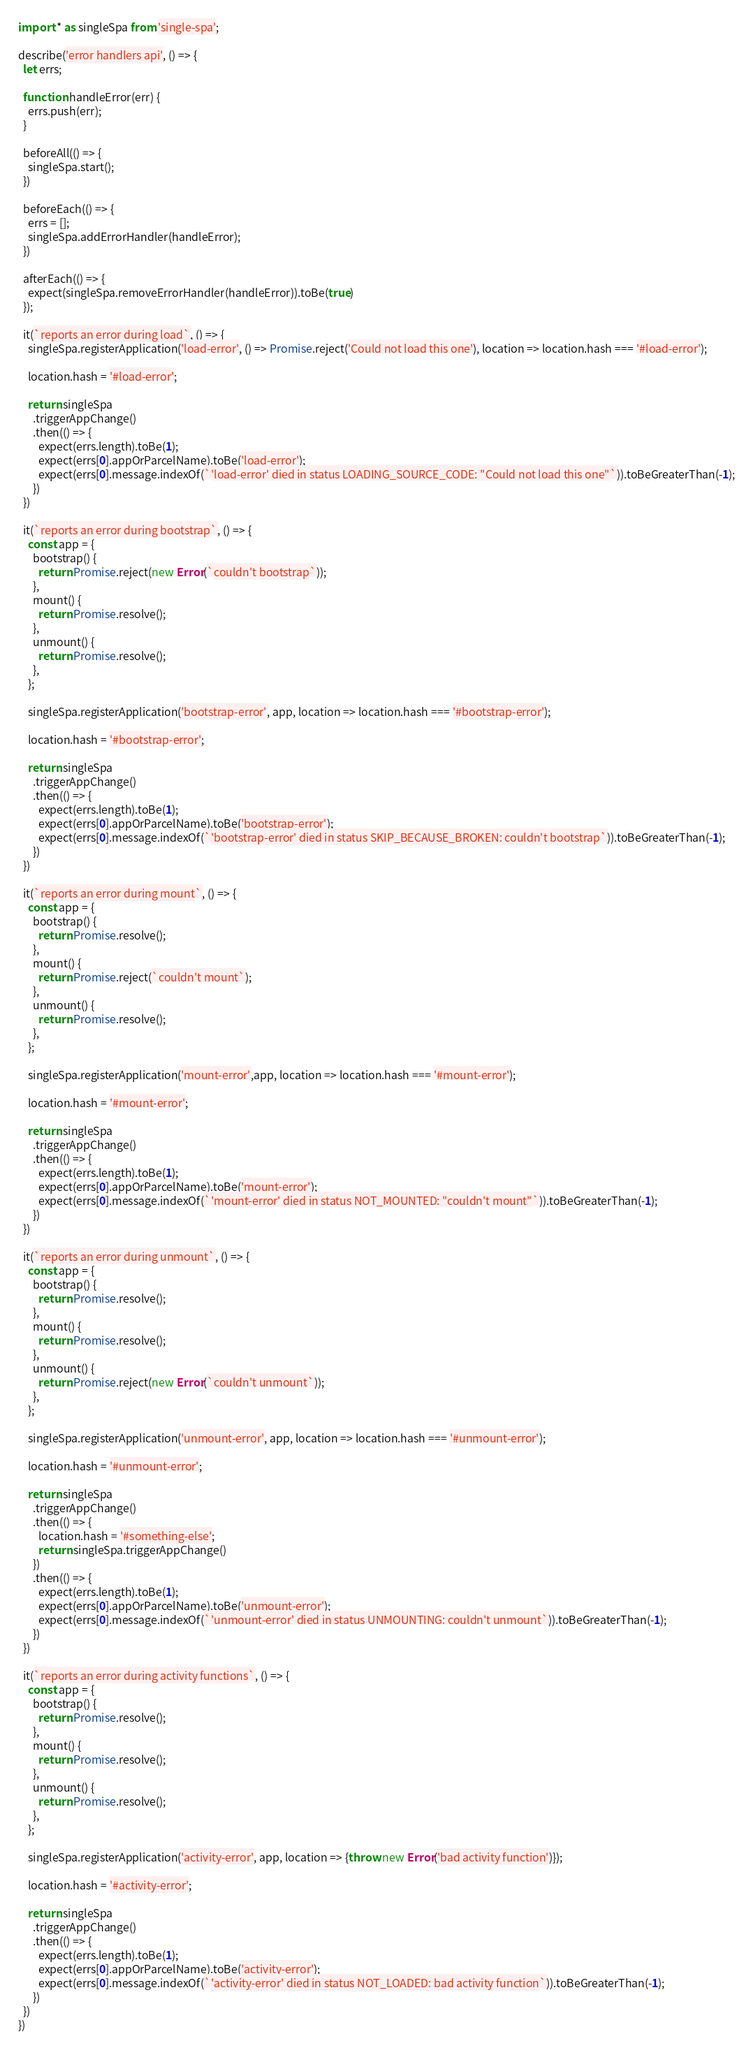Convert code to text. <code><loc_0><loc_0><loc_500><loc_500><_JavaScript_>import * as singleSpa from 'single-spa';

describe('error handlers api', () => {
  let errs;

  function handleError(err) {
    errs.push(err);
  }

  beforeAll(() => {
    singleSpa.start();
  })

  beforeEach(() => {
    errs = [];
    singleSpa.addErrorHandler(handleError);
  })

  afterEach(() => {
    expect(singleSpa.removeErrorHandler(handleError)).toBe(true)
  });

  it(`reports an error during load`, () => {
    singleSpa.registerApplication('load-error', () => Promise.reject('Could not load this one'), location => location.hash === '#load-error');

    location.hash = '#load-error';

    return singleSpa
      .triggerAppChange()
      .then(() => {
        expect(errs.length).toBe(1);
        expect(errs[0].appOrParcelName).toBe('load-error');
        expect(errs[0].message.indexOf(`'load-error' died in status LOADING_SOURCE_CODE: "Could not load this one"`)).toBeGreaterThan(-1);
      })
  })

  it(`reports an error during bootstrap`, () => {
    const app = {
      bootstrap() {
        return Promise.reject(new Error(`couldn't bootstrap`));
      },
      mount() {
        return Promise.resolve();
      },
      unmount() {
        return Promise.resolve();
      },
    };

    singleSpa.registerApplication('bootstrap-error', app, location => location.hash === '#bootstrap-error');

    location.hash = '#bootstrap-error';

    return singleSpa
      .triggerAppChange()
      .then(() => {
        expect(errs.length).toBe(1);
        expect(errs[0].appOrParcelName).toBe('bootstrap-error');
        expect(errs[0].message.indexOf(`'bootstrap-error' died in status SKIP_BECAUSE_BROKEN: couldn't bootstrap`)).toBeGreaterThan(-1);
      })
  })

  it(`reports an error during mount`, () => {
    const app = {
      bootstrap() {
        return Promise.resolve();
      },
      mount() {
        return Promise.reject(`couldn't mount`);
      },
      unmount() {
        return Promise.resolve();
      },
    };

    singleSpa.registerApplication('mount-error',app, location => location.hash === '#mount-error');

    location.hash = '#mount-error';

    return singleSpa
      .triggerAppChange()
      .then(() => {
        expect(errs.length).toBe(1);
        expect(errs[0].appOrParcelName).toBe('mount-error');
        expect(errs[0].message.indexOf(`'mount-error' died in status NOT_MOUNTED: "couldn't mount"`)).toBeGreaterThan(-1);
      })
  })

  it(`reports an error during unmount`, () => {
    const app = {
      bootstrap() {
        return Promise.resolve();
      },
      mount() {
        return Promise.resolve();
      },
      unmount() {
        return Promise.reject(new Error(`couldn't unmount`));
      },
    };

    singleSpa.registerApplication('unmount-error', app, location => location.hash === '#unmount-error');

    location.hash = '#unmount-error';

    return singleSpa
      .triggerAppChange()
      .then(() => {
        location.hash = '#something-else';
        return singleSpa.triggerAppChange()
      })
      .then(() => {
        expect(errs.length).toBe(1);
        expect(errs[0].appOrParcelName).toBe('unmount-error');
        expect(errs[0].message.indexOf(`'unmount-error' died in status UNMOUNTING: couldn't unmount`)).toBeGreaterThan(-1);
      })
  })

  it(`reports an error during activity functions`, () => {
    const app = {
      bootstrap() {
        return Promise.resolve();
      },
      mount() {
        return Promise.resolve();
      },
      unmount() {
        return Promise.resolve();
      },
    };

    singleSpa.registerApplication('activity-error', app, location => {throw new Error('bad activity function')});

    location.hash = '#activity-error';

    return singleSpa
      .triggerAppChange()
      .then(() => {
        expect(errs.length).toBe(1);
        expect(errs[0].appOrParcelName).toBe('activity-error');
        expect(errs[0].message.indexOf(`'activity-error' died in status NOT_LOADED: bad activity function`)).toBeGreaterThan(-1);
      })
  })
})
</code> 